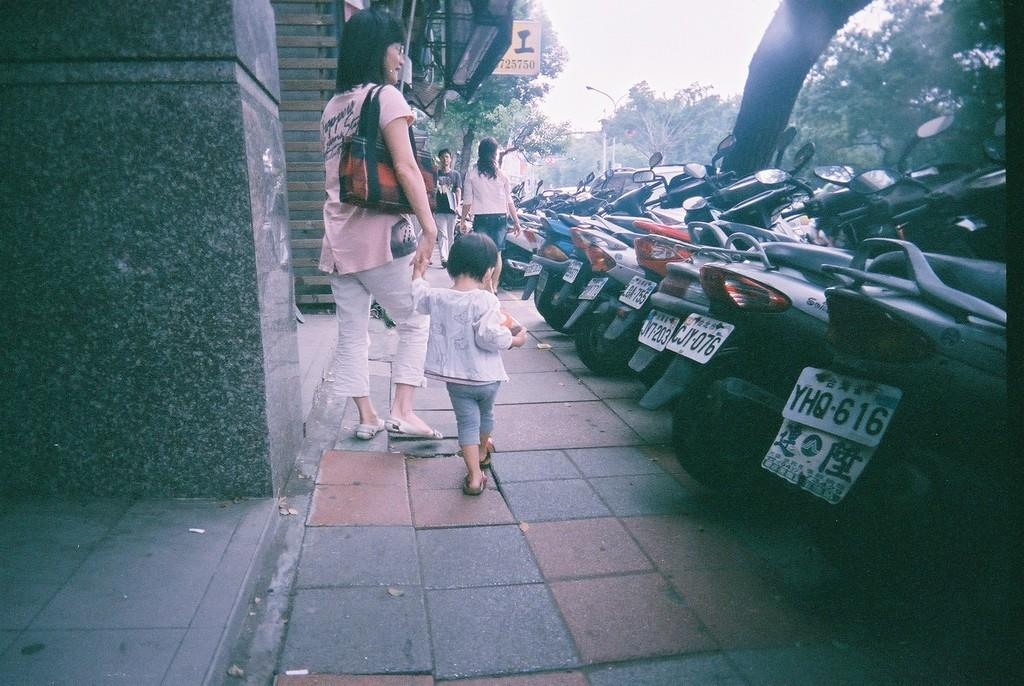What are the people in the image doing? The people in the image are standing on the ground. What can be seen in the background of the image? Vehicles, trees, street lights, a sign board, and the sky are visible in the background of the image. What else is present on the ground in the image? There are other objects on the ground in the image. What decision did the ducks make in the image? There are no ducks present in the image, so no decision can be made by them. 